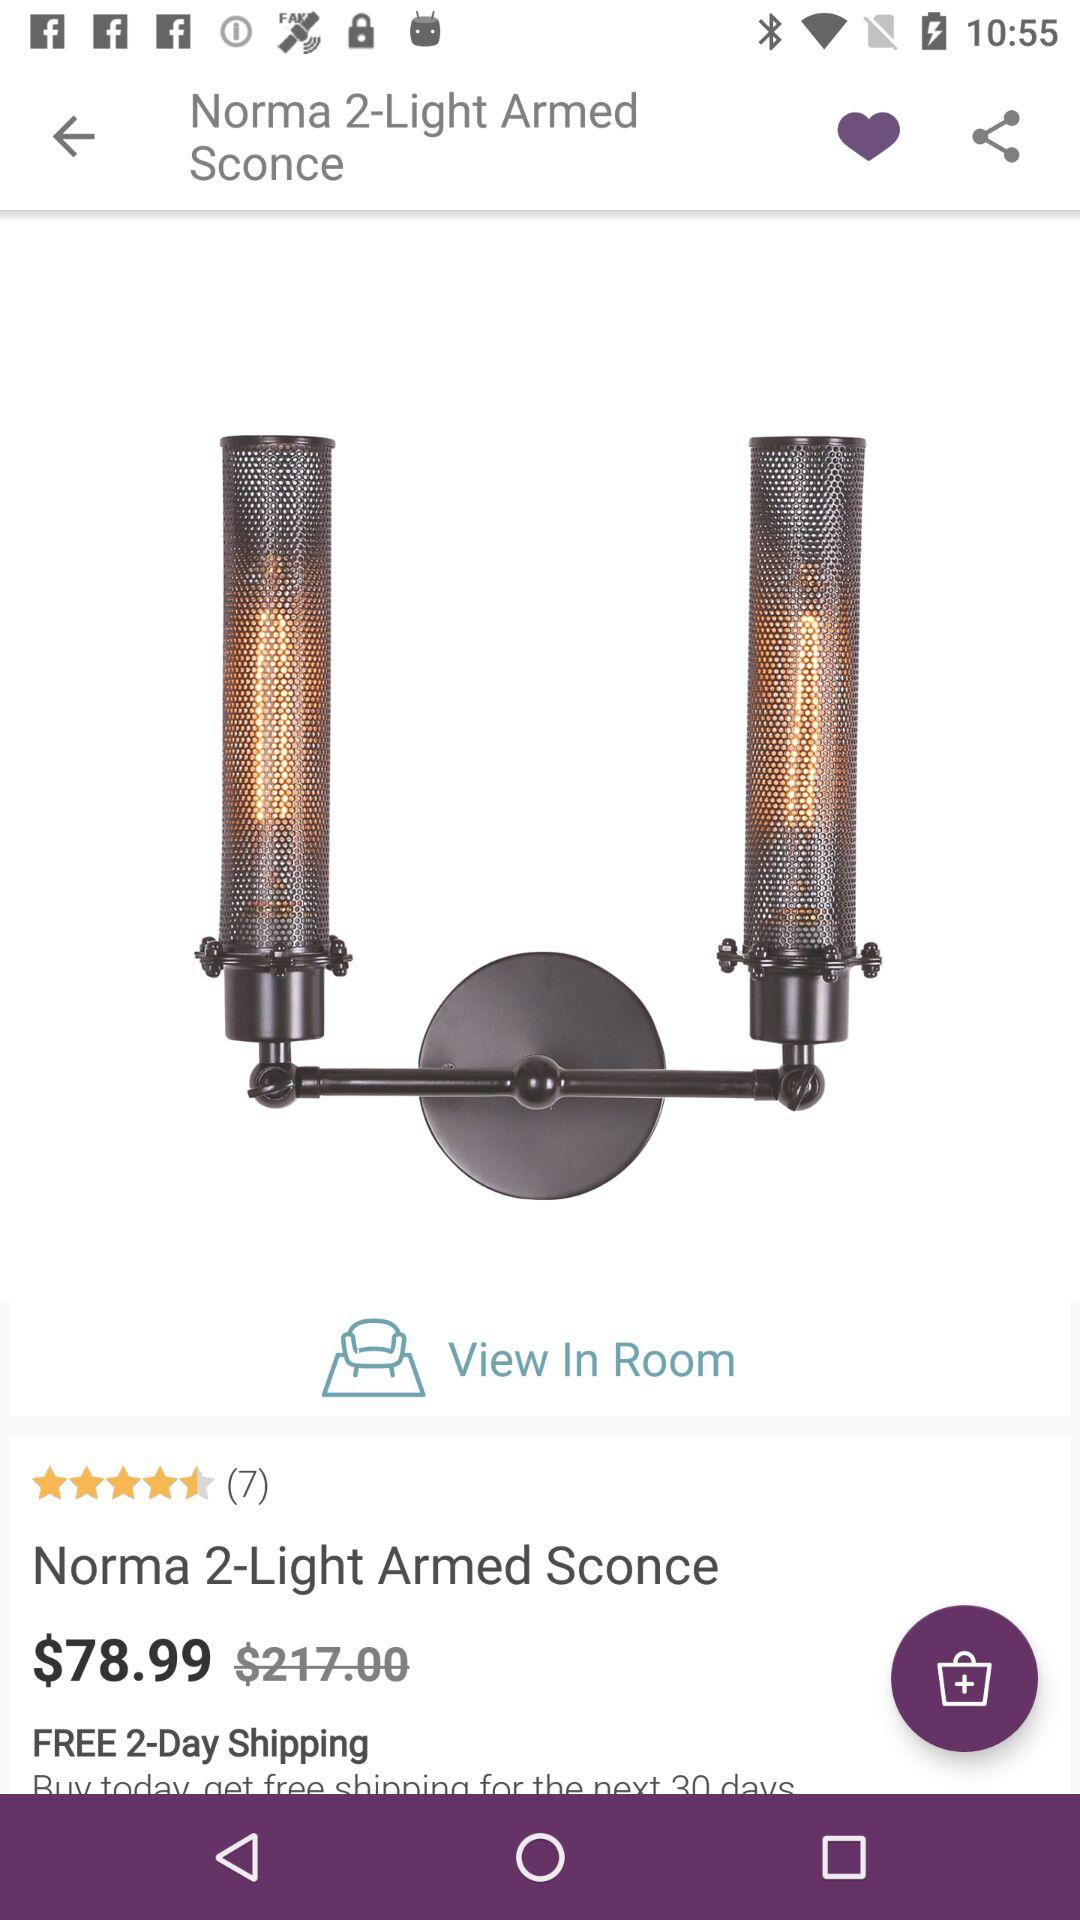What is the star rating of the "Norma 2-Light Armed Sconce"? The rating is 4.5 stars. 